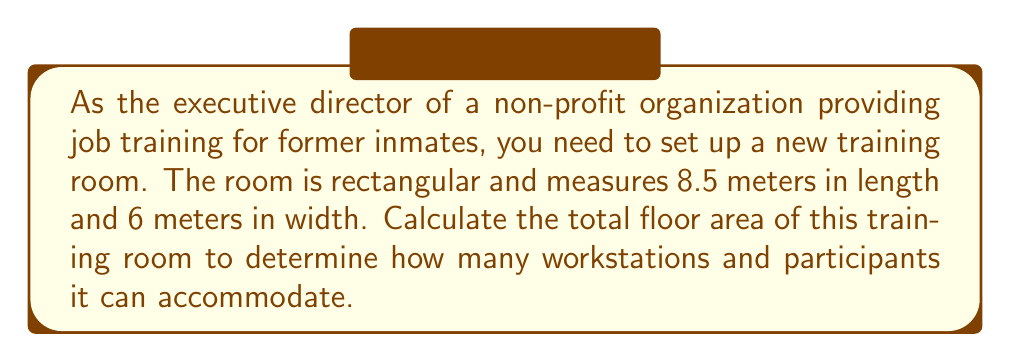What is the answer to this math problem? To calculate the area of a rectangular room, we use the formula:

$$A = l \times w$$

Where:
$A$ = Area
$l$ = Length
$w$ = Width

Given:
Length ($l$) = 8.5 meters
Width ($w$) = 6 meters

Let's substitute these values into the formula:

$$\begin{align}
A &= l \times w \\
A &= 8.5 \text{ m} \times 6 \text{ m} \\
A &= 51 \text{ m}^2
\end{align}$$

[asy]
unitsize(1cm);
draw((0,0)--(8.5,0)--(8.5,6)--(0,6)--cycle);
label("8.5 m", (4.25,0), S);
label("6 m", (8.5,3), E);
label("Training Room", (4.25,3), N);
[/asy]

The calculation shows that the total floor area of the training room is 51 square meters.
Answer: The total floor area of the training room is $51 \text{ m}^2$. 